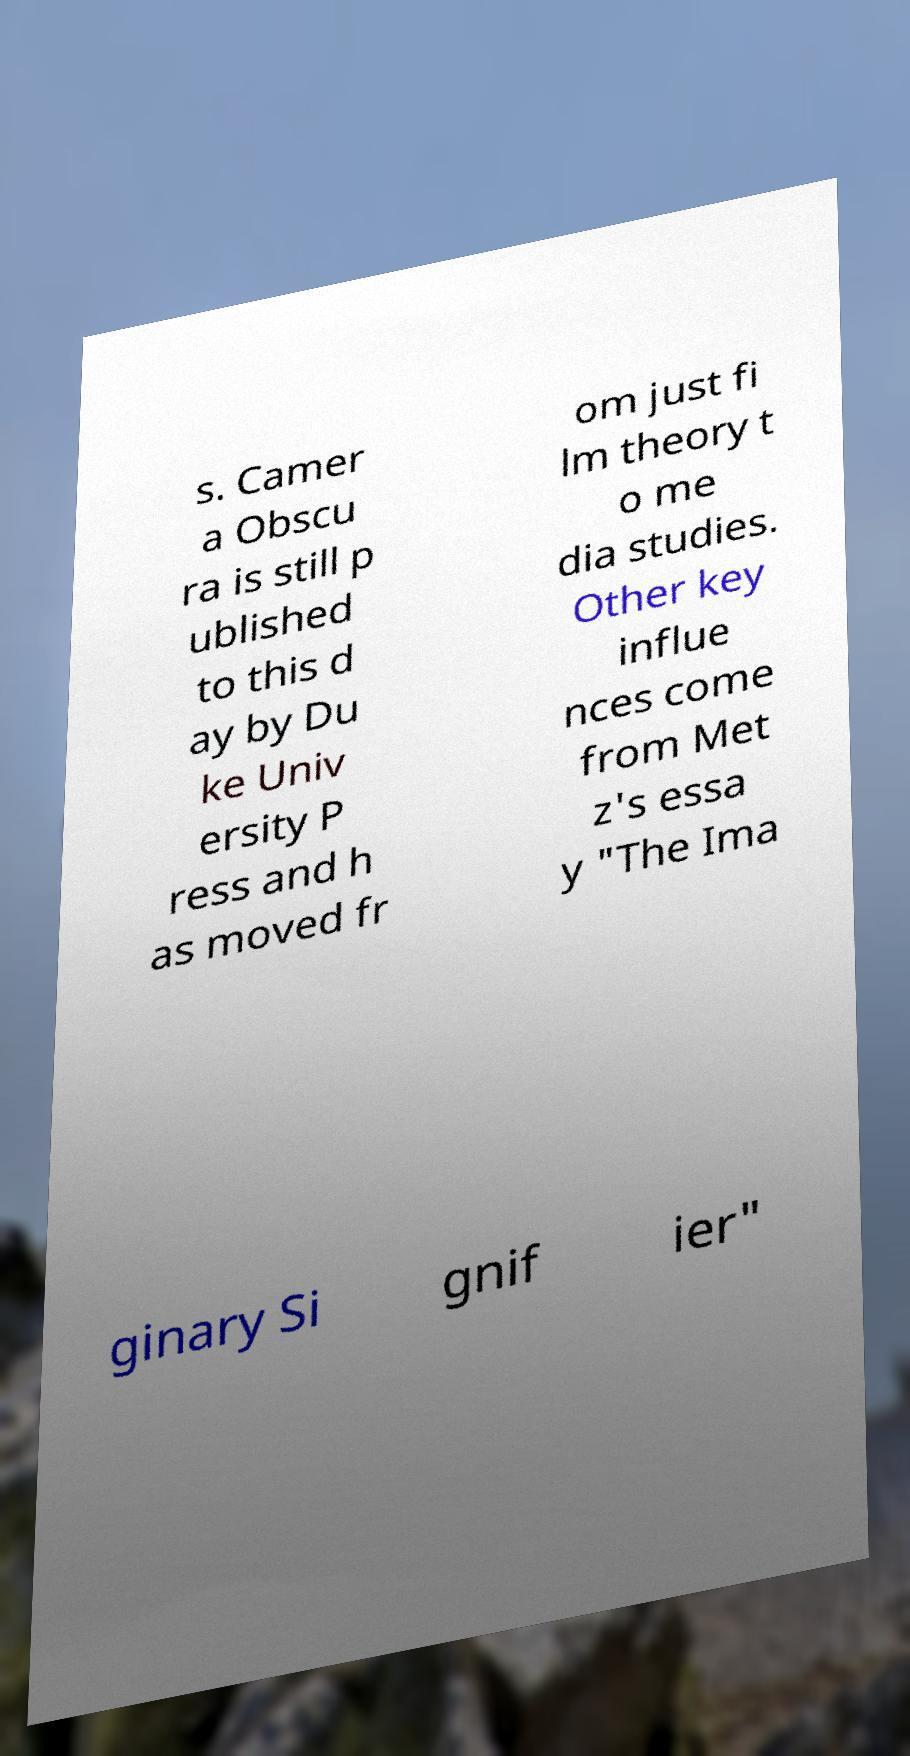Could you assist in decoding the text presented in this image and type it out clearly? s. Camer a Obscu ra is still p ublished to this d ay by Du ke Univ ersity P ress and h as moved fr om just fi lm theory t o me dia studies. Other key influe nces come from Met z's essa y "The Ima ginary Si gnif ier" 